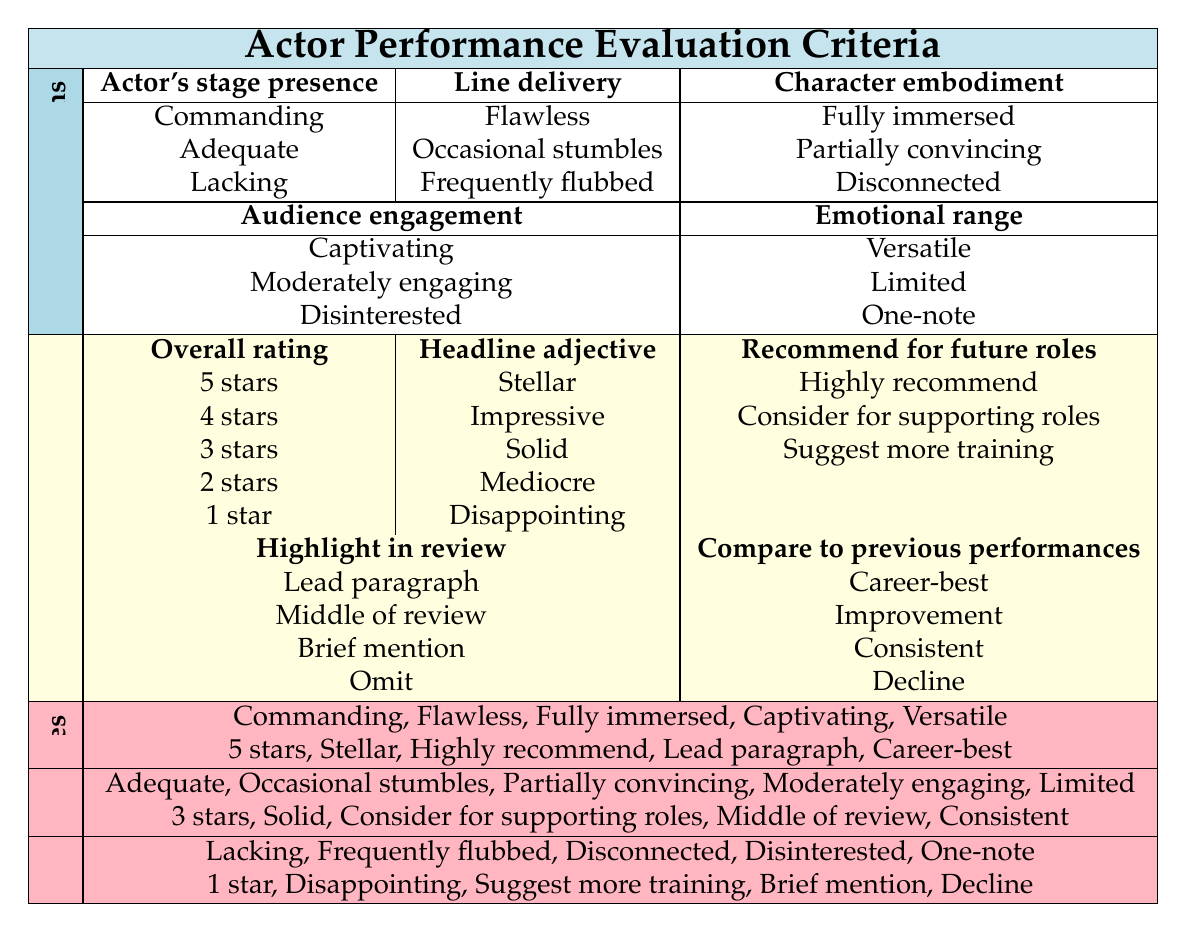What is the overall rating for an actor with a commanding presence, flawless line delivery, fully immersed character embodiment, captivating audience engagement, and versatile emotional range? The conditions given for this scenario match the first rule in the table. According to that rule, the actions correspond to ratings and the other descriptors. The overall rating based on these conditions is 5 stars.
Answer: 5 stars What headline adjective is assigned to an actor delivering lines that are occasionally stumbled over but is moderately engaging? The conditions mention "Occasional stumbles" for line delivery and "Moderately engaging" for audience engagement. Referencing the second rule, these conditions yield the action of "Solid" for the headline adjective.
Answer: Solid Is an actor with a lacking stage presence and frequently flubbed lines considered for future roles? Yes, the conditions mentioned fall into the third rule, which suggests the action of "Suggest more training." This implies some consideration for the actor's future.
Answer: Yes What highlight in the review would an actor with adequate stage presence, occasional line stumbles, and partial character embodiment receive? The conditions indicate "Adequate," "Occasional stumbles," and "Partially convincing," which correspond to the actions dictated by the second rule. The action assigned is "Middle of review."
Answer: Middle of review For an actor described with captivating audience engagement and limited emotional range, what can you say about their performance compared to previous performances? The conditions specify "Captivating" engagement and "Limited" emotional range. Referencing the second rule, it corresponds to the action "Consistent" regarding their performance compared to past performances.
Answer: Consistent How many stars would an actor receive if they display disinterested audience engagement, disconnected character embodiment, and frequent line flubs? The conditions indicate "Disinterested," "Disconnected," and "Frequently flubbed," which match the third rule. The overall rating for this combination is 1 star.
Answer: 1 star Would an actor with flawless line delivery and versatile emotional range receive a poor review? No, according to the table's first rule, flawless line delivery and versatile emotional range yield a positive rating. The actions assigned correspond to a highly favorable review.
Answer: No What is the overall rating for an actor who has a solid performance but lacks emotional range? The conditions suggest "Adequate" for stage presence and "Limited" for emotional range. Referencing the second rule, this condition corresponds to an overall rating of 3 stars.
Answer: 3 stars 